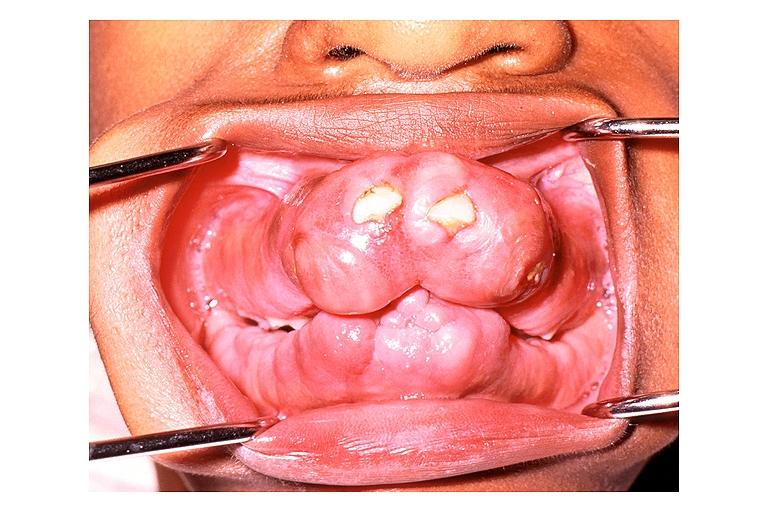what does this image show?
Answer the question using a single word or phrase. Gingival fibromatosis 